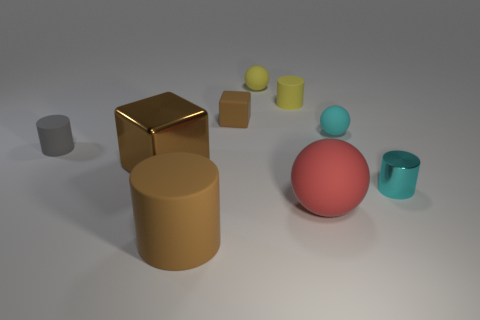Are there any tiny cyan balls made of the same material as the gray thing?
Make the answer very short. Yes. Are there any yellow cylinders that are in front of the small cyan thing in front of the tiny gray matte cylinder?
Provide a short and direct response. No. There is a cube in front of the small cyan ball; what is its material?
Provide a short and direct response. Metal. Is the small cyan shiny object the same shape as the small brown rubber thing?
Offer a very short reply. No. What color is the small matte cylinder that is on the left side of the brown rubber thing that is in front of the tiny sphere that is on the right side of the small yellow ball?
Provide a short and direct response. Gray. What number of brown shiny objects have the same shape as the cyan rubber object?
Ensure brevity in your answer.  0. What size is the matte cylinder that is behind the rubber thing that is to the left of the large brown cylinder?
Make the answer very short. Small. Do the brown metal thing and the yellow matte ball have the same size?
Ensure brevity in your answer.  No. There is a small cylinder that is to the left of the tiny matte cylinder to the right of the big brown cylinder; is there a large brown rubber cylinder to the left of it?
Make the answer very short. No. The cyan cylinder is what size?
Your response must be concise. Small. 